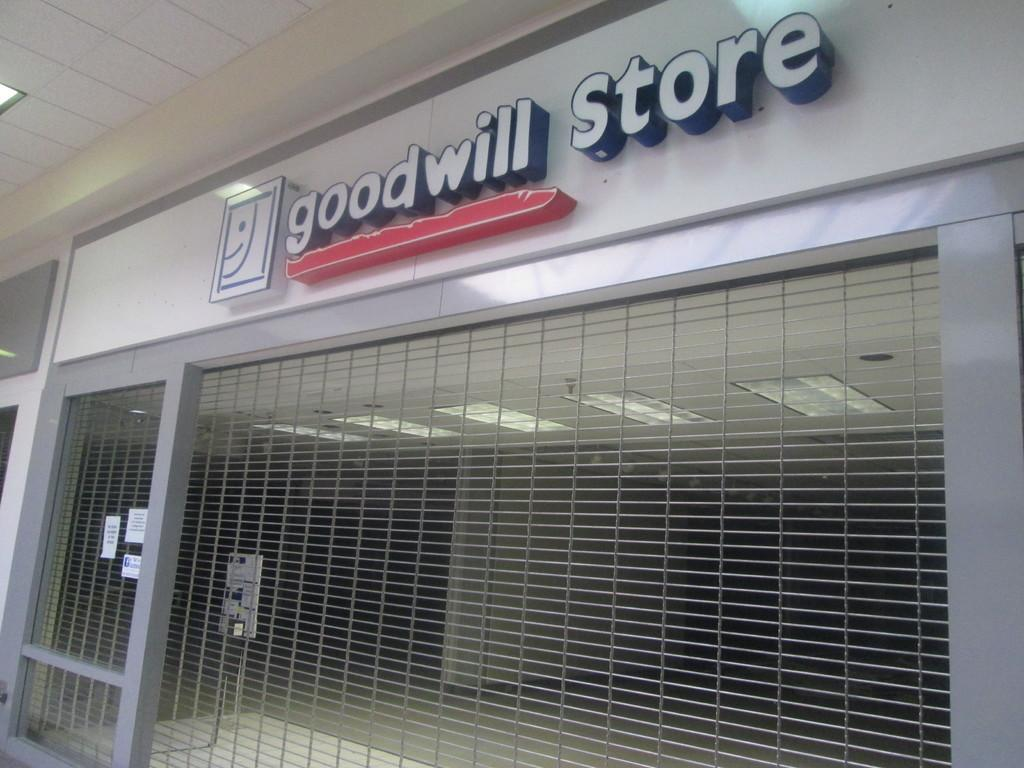What is located at the bottom of the image? There is a fencing gate in the bottom of the image. What can be seen at the top of the image? There is a text board on the top of the image. What is visible in the background of the image? There is a wall in the background of the image. What type of iron is being used to play with the balls in the image? There is no iron or balls present in the image; it features a fencing gate, a text board, and a wall. 